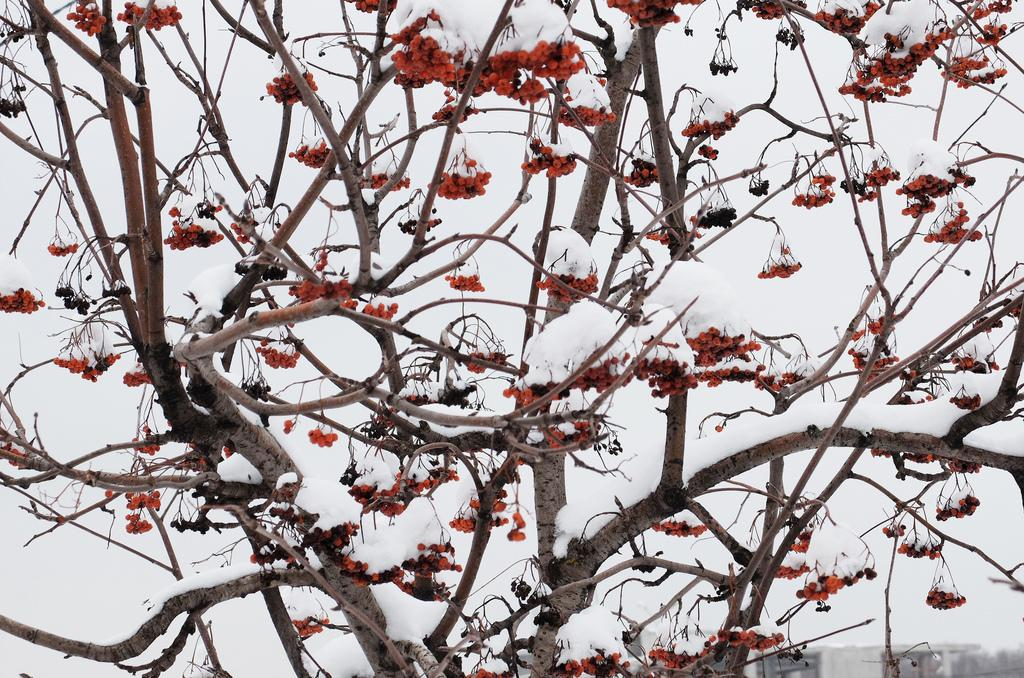What type of vegetation can be seen in the foreground of the image? There are fruits on a tree in the foreground of the image. What is the weather condition in the image? There is snow visible in the image. How many beds are visible in the image? There are no beds present in the image. What type of natural disaster is occurring in the image? There is no indication of a natural disaster in the image; it simply shows a tree with fruits and snow. 